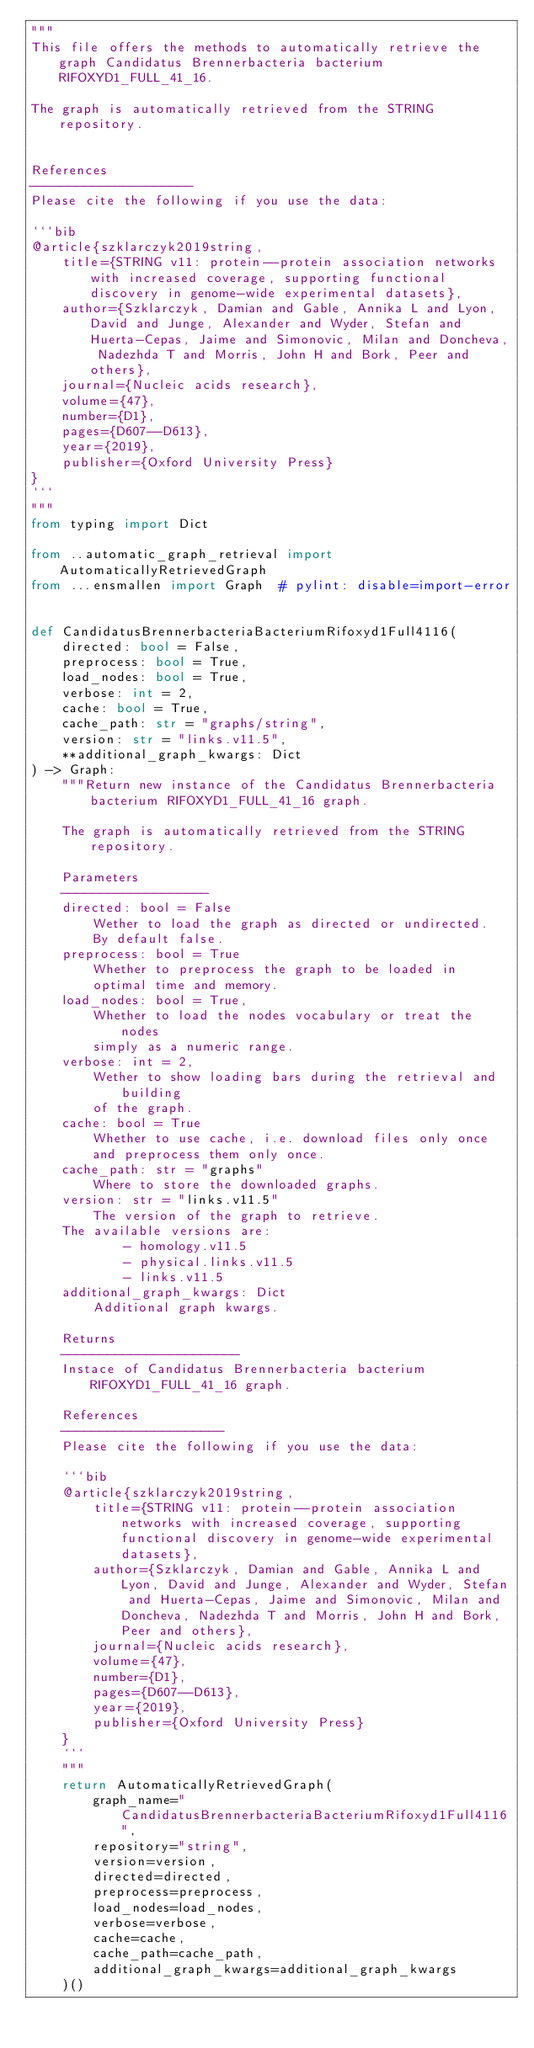<code> <loc_0><loc_0><loc_500><loc_500><_Python_>"""
This file offers the methods to automatically retrieve the graph Candidatus Brennerbacteria bacterium RIFOXYD1_FULL_41_16.

The graph is automatically retrieved from the STRING repository. 


References
---------------------
Please cite the following if you use the data:

```bib
@article{szklarczyk2019string,
    title={STRING v11: protein--protein association networks with increased coverage, supporting functional discovery in genome-wide experimental datasets},
    author={Szklarczyk, Damian and Gable, Annika L and Lyon, David and Junge, Alexander and Wyder, Stefan and Huerta-Cepas, Jaime and Simonovic, Milan and Doncheva, Nadezhda T and Morris, John H and Bork, Peer and others},
    journal={Nucleic acids research},
    volume={47},
    number={D1},
    pages={D607--D613},
    year={2019},
    publisher={Oxford University Press}
}
```
"""
from typing import Dict

from ..automatic_graph_retrieval import AutomaticallyRetrievedGraph
from ...ensmallen import Graph  # pylint: disable=import-error


def CandidatusBrennerbacteriaBacteriumRifoxyd1Full4116(
    directed: bool = False,
    preprocess: bool = True,
    load_nodes: bool = True,
    verbose: int = 2,
    cache: bool = True,
    cache_path: str = "graphs/string",
    version: str = "links.v11.5",
    **additional_graph_kwargs: Dict
) -> Graph:
    """Return new instance of the Candidatus Brennerbacteria bacterium RIFOXYD1_FULL_41_16 graph.

    The graph is automatically retrieved from the STRING repository.	

    Parameters
    -------------------
    directed: bool = False
        Wether to load the graph as directed or undirected.
        By default false.
    preprocess: bool = True
        Whether to preprocess the graph to be loaded in 
        optimal time and memory.
    load_nodes: bool = True,
        Whether to load the nodes vocabulary or treat the nodes
        simply as a numeric range.
    verbose: int = 2,
        Wether to show loading bars during the retrieval and building
        of the graph.
    cache: bool = True
        Whether to use cache, i.e. download files only once
        and preprocess them only once.
    cache_path: str = "graphs"
        Where to store the downloaded graphs.
    version: str = "links.v11.5"
        The version of the graph to retrieve.		
	The available versions are:
			- homology.v11.5
			- physical.links.v11.5
			- links.v11.5
    additional_graph_kwargs: Dict
        Additional graph kwargs.

    Returns
    -----------------------
    Instace of Candidatus Brennerbacteria bacterium RIFOXYD1_FULL_41_16 graph.

	References
	---------------------
	Please cite the following if you use the data:
	
	```bib
	@article{szklarczyk2019string,
	    title={STRING v11: protein--protein association networks with increased coverage, supporting functional discovery in genome-wide experimental datasets},
	    author={Szklarczyk, Damian and Gable, Annika L and Lyon, David and Junge, Alexander and Wyder, Stefan and Huerta-Cepas, Jaime and Simonovic, Milan and Doncheva, Nadezhda T and Morris, John H and Bork, Peer and others},
	    journal={Nucleic acids research},
	    volume={47},
	    number={D1},
	    pages={D607--D613},
	    year={2019},
	    publisher={Oxford University Press}
	}
	```
    """
    return AutomaticallyRetrievedGraph(
        graph_name="CandidatusBrennerbacteriaBacteriumRifoxyd1Full4116",
        repository="string",
        version=version,
        directed=directed,
        preprocess=preprocess,
        load_nodes=load_nodes,
        verbose=verbose,
        cache=cache,
        cache_path=cache_path,
        additional_graph_kwargs=additional_graph_kwargs
    )()
</code> 